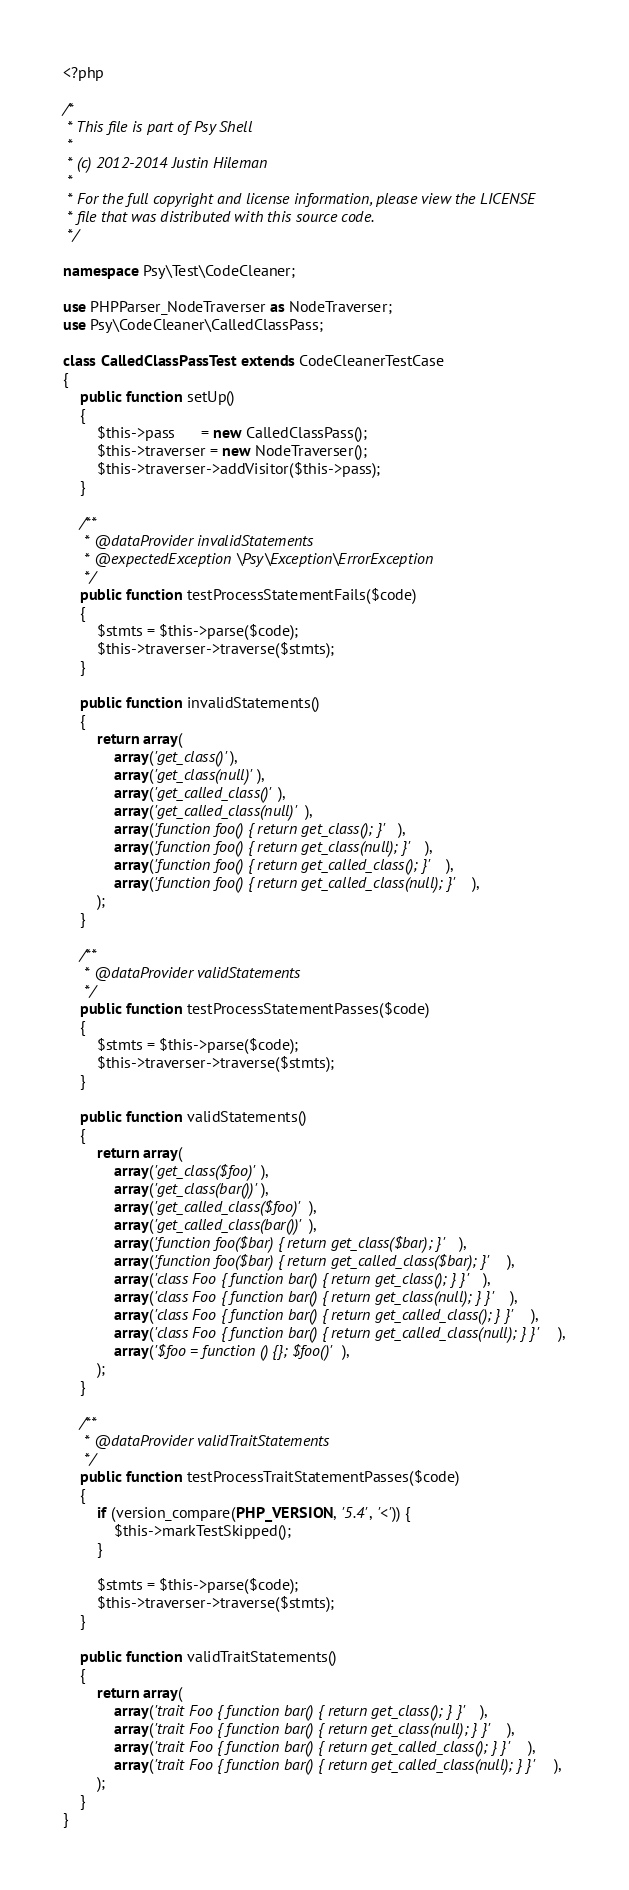<code> <loc_0><loc_0><loc_500><loc_500><_PHP_><?php

/*
 * This file is part of Psy Shell
 *
 * (c) 2012-2014 Justin Hileman
 *
 * For the full copyright and license information, please view the LICENSE
 * file that was distributed with this source code.
 */

namespace Psy\Test\CodeCleaner;

use PHPParser_NodeTraverser as NodeTraverser;
use Psy\CodeCleaner\CalledClassPass;

class CalledClassPassTest extends CodeCleanerTestCase
{
    public function setUp()
    {
        $this->pass      = new CalledClassPass();
        $this->traverser = new NodeTraverser();
        $this->traverser->addVisitor($this->pass);
    }

    /**
     * @dataProvider invalidStatements
     * @expectedException \Psy\Exception\ErrorException
     */
    public function testProcessStatementFails($code)
    {
        $stmts = $this->parse($code);
        $this->traverser->traverse($stmts);
    }

    public function invalidStatements()
    {
        return array(
            array('get_class()'),
            array('get_class(null)'),
            array('get_called_class()'),
            array('get_called_class(null)'),
            array('function foo() { return get_class(); }'),
            array('function foo() { return get_class(null); }'),
            array('function foo() { return get_called_class(); }'),
            array('function foo() { return get_called_class(null); }'),
        );
    }

    /**
     * @dataProvider validStatements
     */
    public function testProcessStatementPasses($code)
    {
        $stmts = $this->parse($code);
        $this->traverser->traverse($stmts);
    }

    public function validStatements()
    {
        return array(
            array('get_class($foo)'),
            array('get_class(bar())'),
            array('get_called_class($foo)'),
            array('get_called_class(bar())'),
            array('function foo($bar) { return get_class($bar); }'),
            array('function foo($bar) { return get_called_class($bar); }'),
            array('class Foo { function bar() { return get_class(); } }'),
            array('class Foo { function bar() { return get_class(null); } }'),
            array('class Foo { function bar() { return get_called_class(); } }'),
            array('class Foo { function bar() { return get_called_class(null); } }'),
            array('$foo = function () {}; $foo()'),
        );
    }

    /**
     * @dataProvider validTraitStatements
     */
    public function testProcessTraitStatementPasses($code)
    {
        if (version_compare(PHP_VERSION, '5.4', '<')) {
            $this->markTestSkipped();
        }

        $stmts = $this->parse($code);
        $this->traverser->traverse($stmts);
    }

    public function validTraitStatements()
    {
        return array(
            array('trait Foo { function bar() { return get_class(); } }'),
            array('trait Foo { function bar() { return get_class(null); } }'),
            array('trait Foo { function bar() { return get_called_class(); } }'),
            array('trait Foo { function bar() { return get_called_class(null); } }'),
        );
    }
}
</code> 